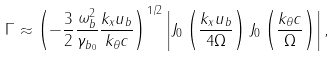Convert formula to latex. <formula><loc_0><loc_0><loc_500><loc_500>\Gamma \approx \left ( - \frac { 3 } { 2 } \frac { \omega ^ { 2 } _ { b } } { \gamma _ { b _ { 0 } } } \frac { k _ { x } u _ { b } } { k _ { \theta } c } \right ) ^ { 1 / 2 } \left | J _ { 0 } \left ( \frac { k _ { x } u _ { b } } { 4 \Omega } \right ) J _ { 0 } \left ( \frac { k _ { \theta } c } { \Omega } \right ) \right | ,</formula> 